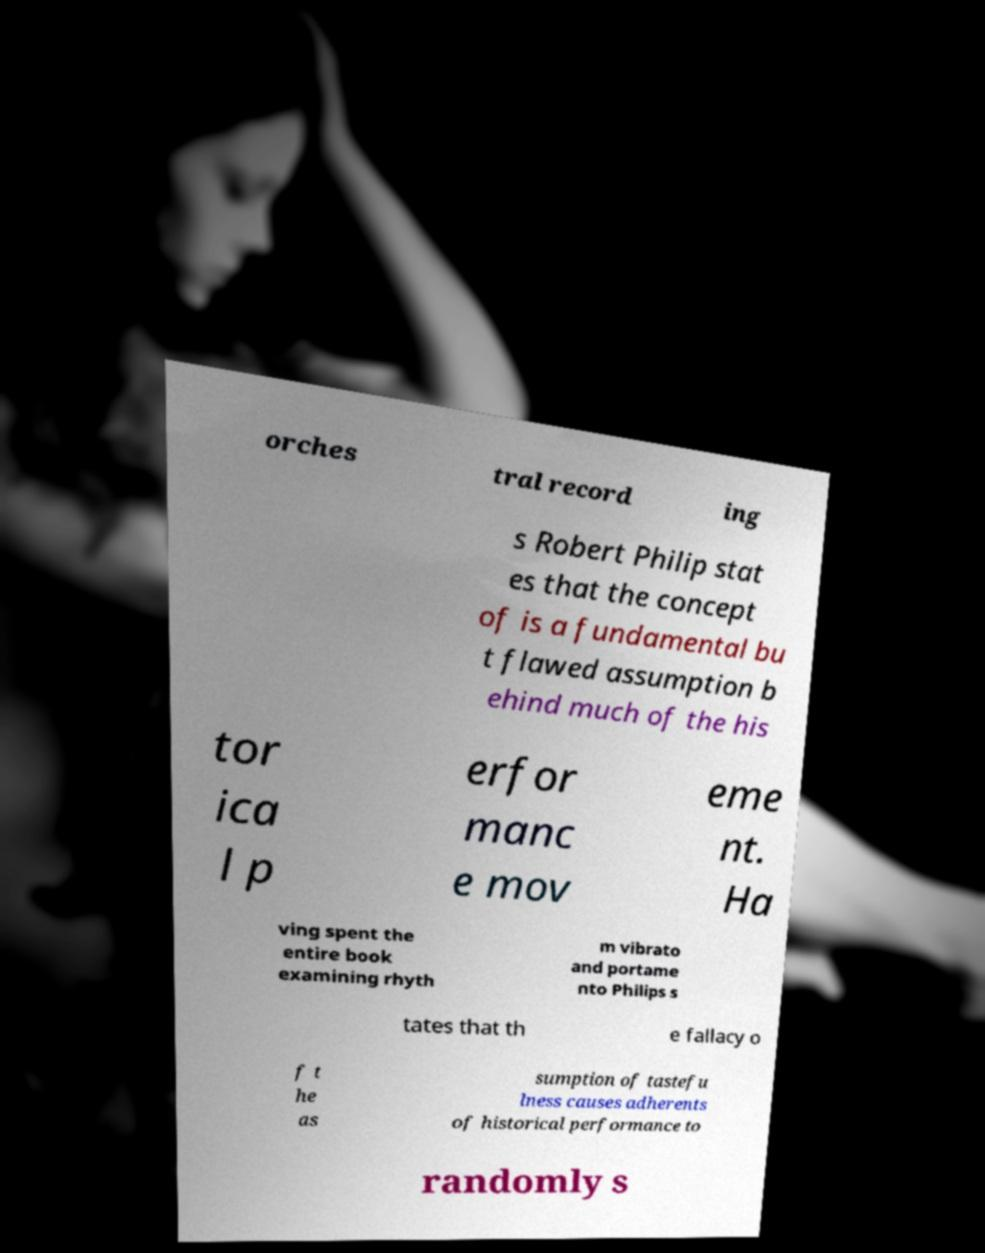Could you extract and type out the text from this image? orches tral record ing s Robert Philip stat es that the concept of is a fundamental bu t flawed assumption b ehind much of the his tor ica l p erfor manc e mov eme nt. Ha ving spent the entire book examining rhyth m vibrato and portame nto Philips s tates that th e fallacy o f t he as sumption of tastefu lness causes adherents of historical performance to randomly s 